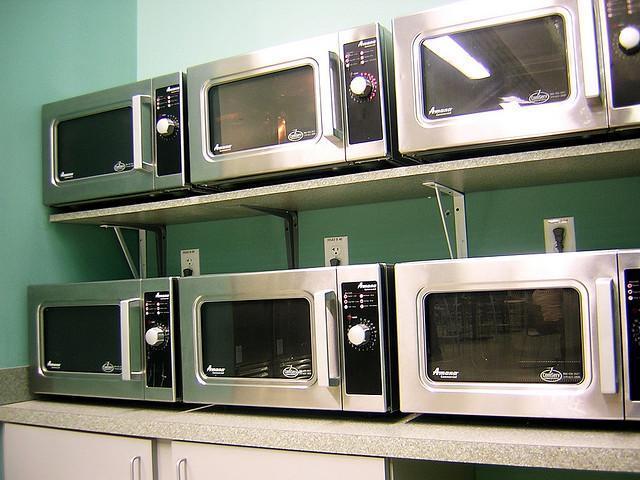How many microwaves are visible?
Give a very brief answer. 6. 